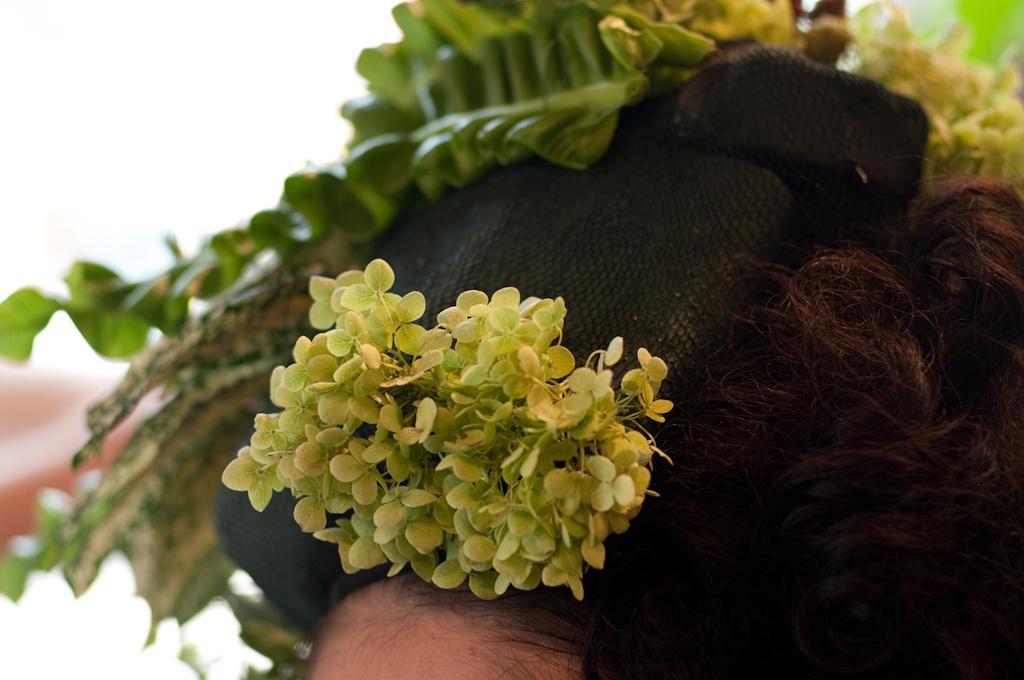How would you summarize this image in a sentence or two? In this image we can see a human head. On the head, we can see a cap, hair and leaves. 